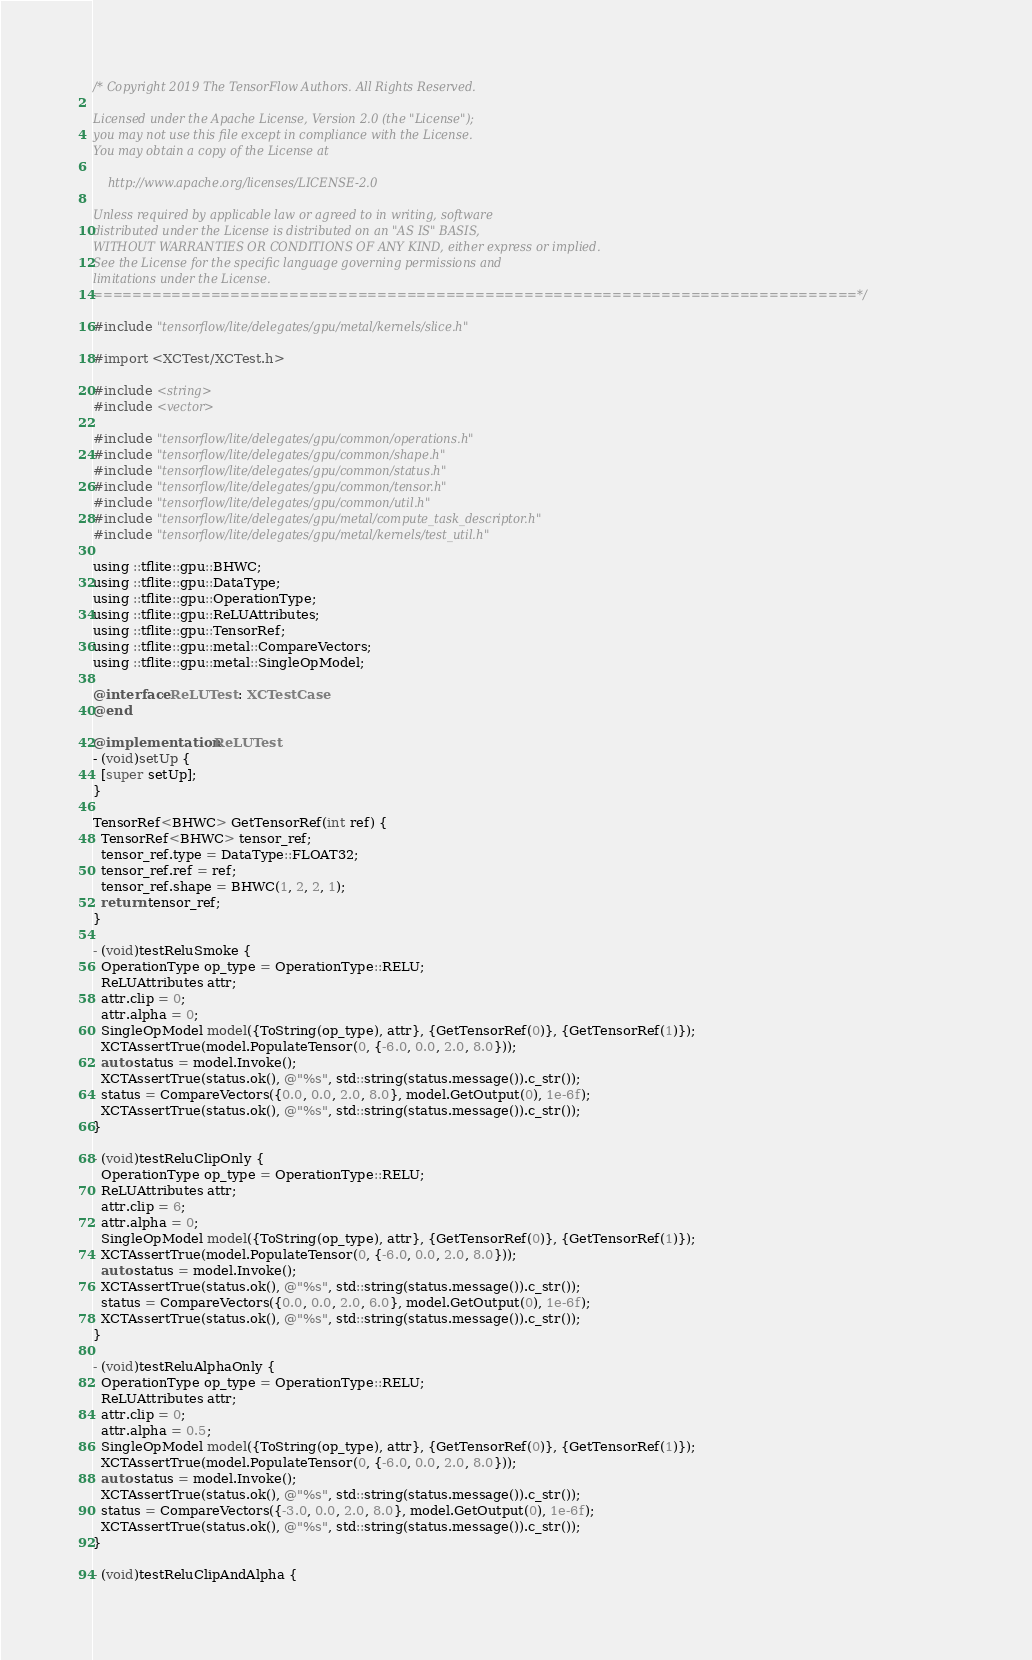Convert code to text. <code><loc_0><loc_0><loc_500><loc_500><_ObjectiveC_>/* Copyright 2019 The TensorFlow Authors. All Rights Reserved.

Licensed under the Apache License, Version 2.0 (the "License");
you may not use this file except in compliance with the License.
You may obtain a copy of the License at

    http://www.apache.org/licenses/LICENSE-2.0

Unless required by applicable law or agreed to in writing, software
distributed under the License is distributed on an "AS IS" BASIS,
WITHOUT WARRANTIES OR CONDITIONS OF ANY KIND, either express or implied.
See the License for the specific language governing permissions and
limitations under the License.
==============================================================================*/

#include "tensorflow/lite/delegates/gpu/metal/kernels/slice.h"

#import <XCTest/XCTest.h>

#include <string>
#include <vector>

#include "tensorflow/lite/delegates/gpu/common/operations.h"
#include "tensorflow/lite/delegates/gpu/common/shape.h"
#include "tensorflow/lite/delegates/gpu/common/status.h"
#include "tensorflow/lite/delegates/gpu/common/tensor.h"
#include "tensorflow/lite/delegates/gpu/common/util.h"
#include "tensorflow/lite/delegates/gpu/metal/compute_task_descriptor.h"
#include "tensorflow/lite/delegates/gpu/metal/kernels/test_util.h"

using ::tflite::gpu::BHWC;
using ::tflite::gpu::DataType;
using ::tflite::gpu::OperationType;
using ::tflite::gpu::ReLUAttributes;
using ::tflite::gpu::TensorRef;
using ::tflite::gpu::metal::CompareVectors;
using ::tflite::gpu::metal::SingleOpModel;

@interface ReLUTest : XCTestCase
@end

@implementation ReLUTest
- (void)setUp {
  [super setUp];
}

TensorRef<BHWC> GetTensorRef(int ref) {
  TensorRef<BHWC> tensor_ref;
  tensor_ref.type = DataType::FLOAT32;
  tensor_ref.ref = ref;
  tensor_ref.shape = BHWC(1, 2, 2, 1);
  return tensor_ref;
}

- (void)testReluSmoke {
  OperationType op_type = OperationType::RELU;
  ReLUAttributes attr;
  attr.clip = 0;
  attr.alpha = 0;
  SingleOpModel model({ToString(op_type), attr}, {GetTensorRef(0)}, {GetTensorRef(1)});
  XCTAssertTrue(model.PopulateTensor(0, {-6.0, 0.0, 2.0, 8.0}));
  auto status = model.Invoke();
  XCTAssertTrue(status.ok(), @"%s", std::string(status.message()).c_str());
  status = CompareVectors({0.0, 0.0, 2.0, 8.0}, model.GetOutput(0), 1e-6f);
  XCTAssertTrue(status.ok(), @"%s", std::string(status.message()).c_str());
}

- (void)testReluClipOnly {
  OperationType op_type = OperationType::RELU;
  ReLUAttributes attr;
  attr.clip = 6;
  attr.alpha = 0;
  SingleOpModel model({ToString(op_type), attr}, {GetTensorRef(0)}, {GetTensorRef(1)});
  XCTAssertTrue(model.PopulateTensor(0, {-6.0, 0.0, 2.0, 8.0}));
  auto status = model.Invoke();
  XCTAssertTrue(status.ok(), @"%s", std::string(status.message()).c_str());
  status = CompareVectors({0.0, 0.0, 2.0, 6.0}, model.GetOutput(0), 1e-6f);
  XCTAssertTrue(status.ok(), @"%s", std::string(status.message()).c_str());
}

- (void)testReluAlphaOnly {
  OperationType op_type = OperationType::RELU;
  ReLUAttributes attr;
  attr.clip = 0;
  attr.alpha = 0.5;
  SingleOpModel model({ToString(op_type), attr}, {GetTensorRef(0)}, {GetTensorRef(1)});
  XCTAssertTrue(model.PopulateTensor(0, {-6.0, 0.0, 2.0, 8.0}));
  auto status = model.Invoke();
  XCTAssertTrue(status.ok(), @"%s", std::string(status.message()).c_str());
  status = CompareVectors({-3.0, 0.0, 2.0, 8.0}, model.GetOutput(0), 1e-6f);
  XCTAssertTrue(status.ok(), @"%s", std::string(status.message()).c_str());
}

- (void)testReluClipAndAlpha {</code> 